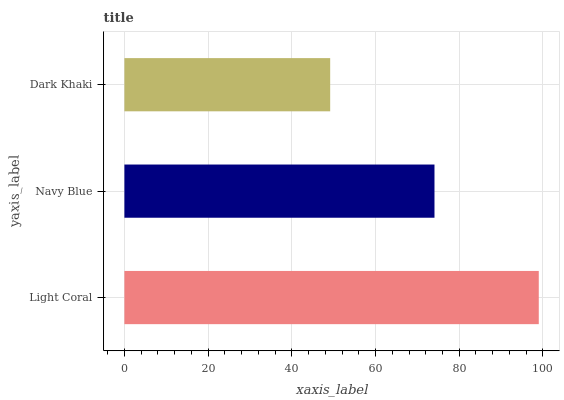Is Dark Khaki the minimum?
Answer yes or no. Yes. Is Light Coral the maximum?
Answer yes or no. Yes. Is Navy Blue the minimum?
Answer yes or no. No. Is Navy Blue the maximum?
Answer yes or no. No. Is Light Coral greater than Navy Blue?
Answer yes or no. Yes. Is Navy Blue less than Light Coral?
Answer yes or no. Yes. Is Navy Blue greater than Light Coral?
Answer yes or no. No. Is Light Coral less than Navy Blue?
Answer yes or no. No. Is Navy Blue the high median?
Answer yes or no. Yes. Is Navy Blue the low median?
Answer yes or no. Yes. Is Light Coral the high median?
Answer yes or no. No. Is Light Coral the low median?
Answer yes or no. No. 